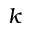Convert formula to latex. <formula><loc_0><loc_0><loc_500><loc_500>k</formula> 